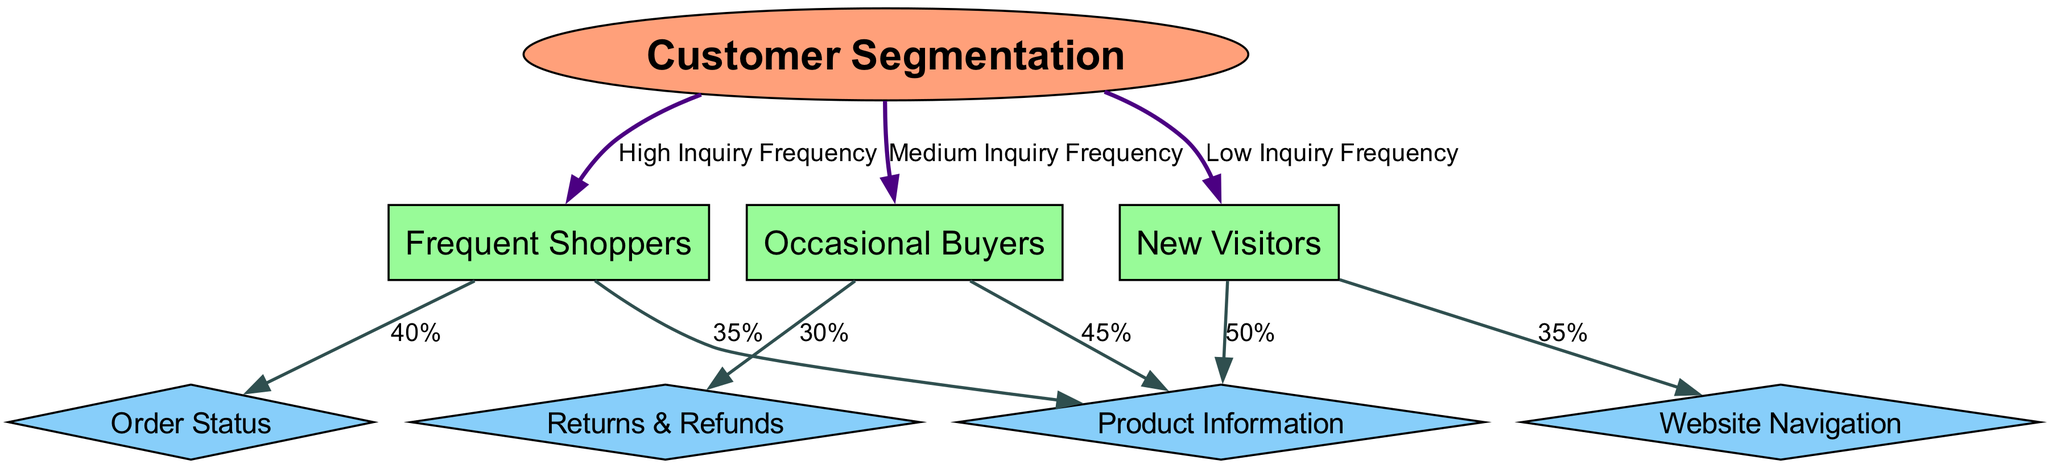What is the total number of nodes in the diagram? The diagram contains eight nodes: one root node labeled "Customer Segmentation," three segment nodes labeled "Frequent Shoppers," "Occasional Buyers," "New Visitors," and four inquiry nodes labeled "Product Information," "Order Status," "Returns & Refunds," and "Website Navigation." Adding them up gives a total of eight nodes.
Answer: 8 What percentage of inquiries from Frequent Shoppers is related to Order Status? In the diagram, the edge from the "Frequent Shoppers" segment to the "Order Status" inquiry shows a label of "40%." This indicates that 40% of inquiries from this segment are about Order Status.
Answer: 40% Which segment has the highest inquiry frequency? The diagram indicates three segments categorized by inquiry frequency: "Frequent Shoppers," "Occasional Buyers," and "New Visitors." The "Frequent Shoppers" segment is labeled as having "High Inquiry Frequency," which can be directly identified from the edge connecting it to the root node.
Answer: Frequent Shoppers What is the percentage of inquiries about Product Information from New Visitors? The diagram shows that the edge from the "New Visitors" segment to the "Product Information" inquiry is labeled "50%." This indicates that half of the inquiries from new visitors are related to product information.
Answer: 50% How many inquiry types are associated with Occasional Buyers? In the diagram, the "Occasional Buyers" segment is connected to two inquiry types: "Product Information" and "Returns & Refunds," as indicated by the edges leading from this segment. Therefore, there are two inquiry types associated with Occasional Buyers.
Answer: 2 Which inquiry type has the highest percentage of inquiries from Occasional Buyers? Looking at the connections from the "Occasional Buyers" segment, the edges show 45% to "Product Information" and 30% to "Returns & Refunds." Therefore, the highest percentage is associated with Product Information because 45% is greater than 30%.
Answer: Product Information What is the relationship between New Visitors and Website Navigation inquiries? The edge from "New Visitors" to "Website Navigation" shows a label of "35%." This indicates that 35% of inquiries from new visitors pertain to website navigation, establishing a direct relationship between the two nodes based on this inquiry type.
Answer: 35% 